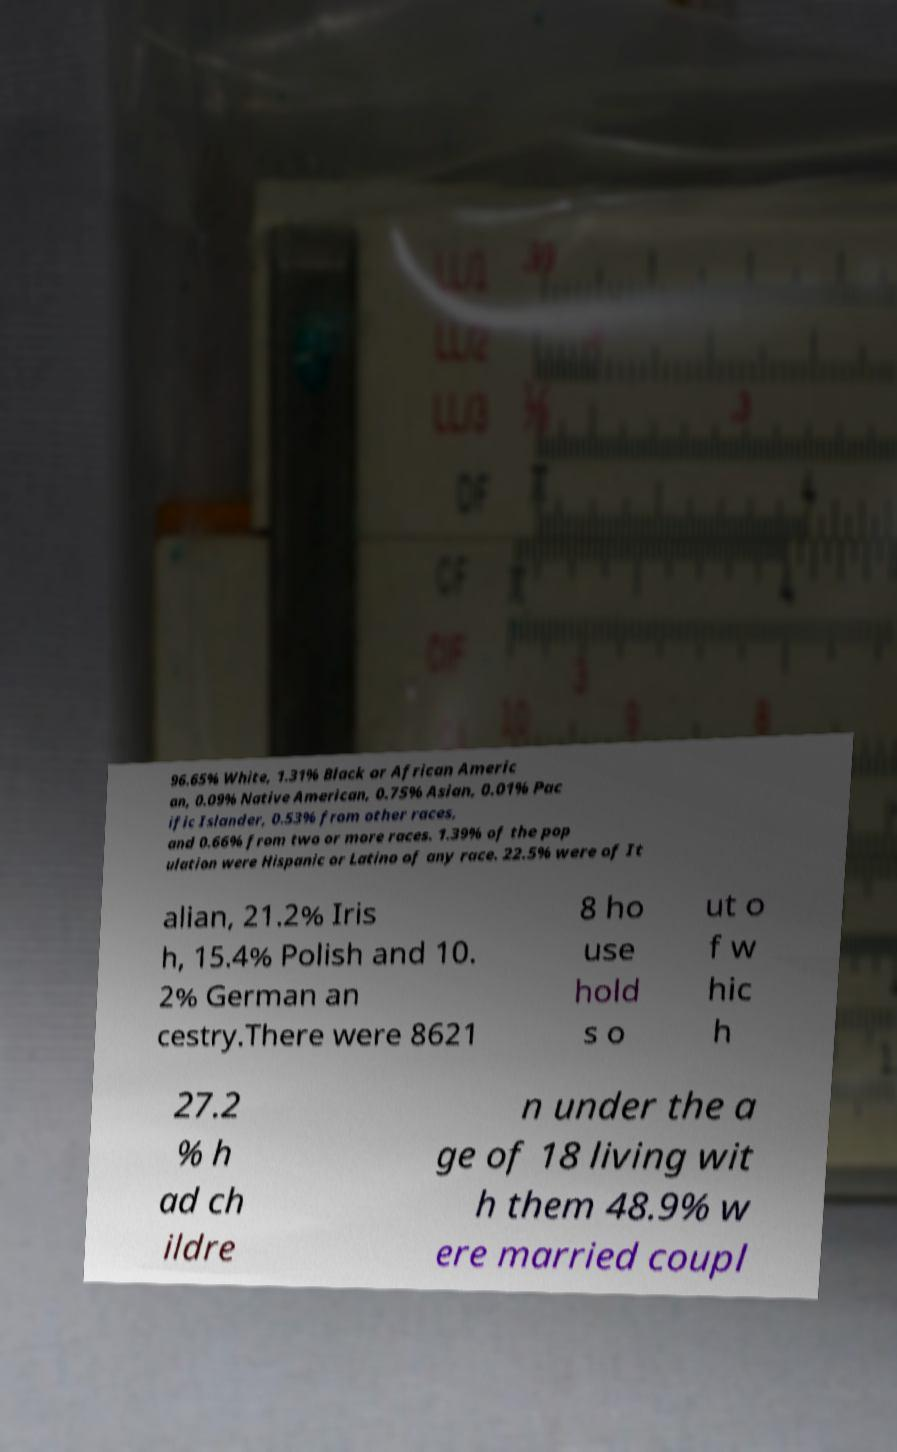What messages or text are displayed in this image? I need them in a readable, typed format. 96.65% White, 1.31% Black or African Americ an, 0.09% Native American, 0.75% Asian, 0.01% Pac ific Islander, 0.53% from other races, and 0.66% from two or more races. 1.39% of the pop ulation were Hispanic or Latino of any race. 22.5% were of It alian, 21.2% Iris h, 15.4% Polish and 10. 2% German an cestry.There were 8621 8 ho use hold s o ut o f w hic h 27.2 % h ad ch ildre n under the a ge of 18 living wit h them 48.9% w ere married coupl 